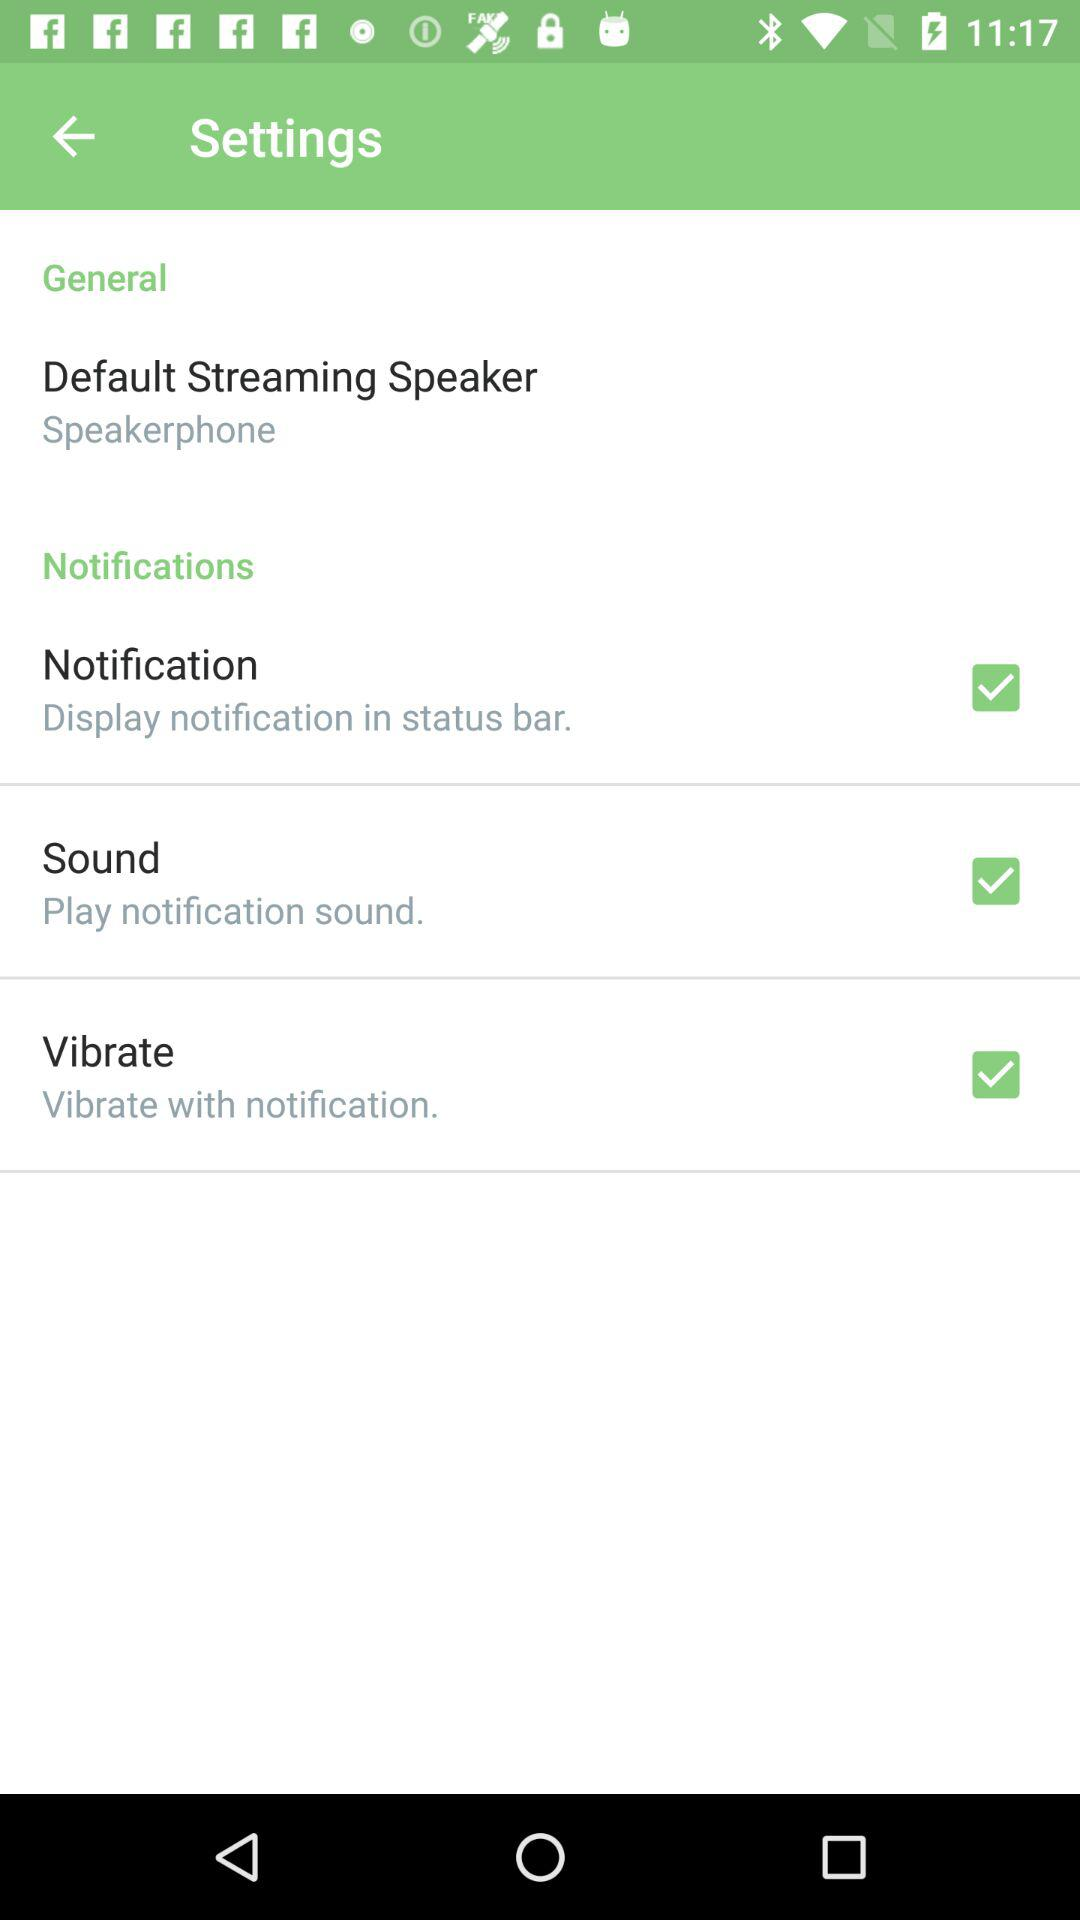How many notification options are there?
Answer the question using a single word or phrase. 3 